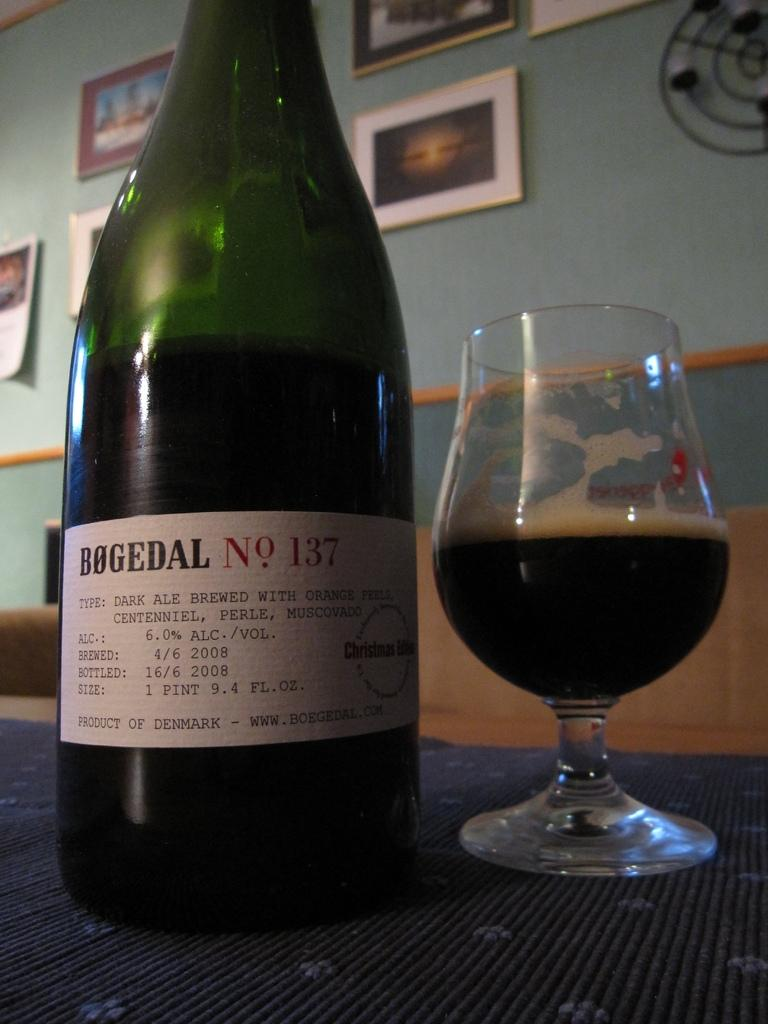What objects are on the table in the image? There is a bottle and a glass on the table in the image. What is the purpose of the bottle and the glass? The bottle and the glass are likely used for holding or serving a beverage. What can be seen on the wall in the background of the image? There are frames attached to a wall in the background of the image. Is the father sitting on a chair in the image? There is no mention of a father or a chair in the image. The image only features a bottle, a glass, and frames on a wall. 